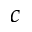<formula> <loc_0><loc_0><loc_500><loc_500>c</formula> 